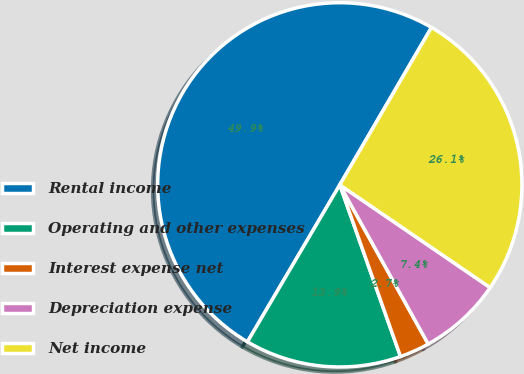<chart> <loc_0><loc_0><loc_500><loc_500><pie_chart><fcel>Rental income<fcel>Operating and other expenses<fcel>Interest expense net<fcel>Depreciation expense<fcel>Net income<nl><fcel>49.93%<fcel>13.87%<fcel>2.66%<fcel>7.39%<fcel>26.14%<nl></chart> 